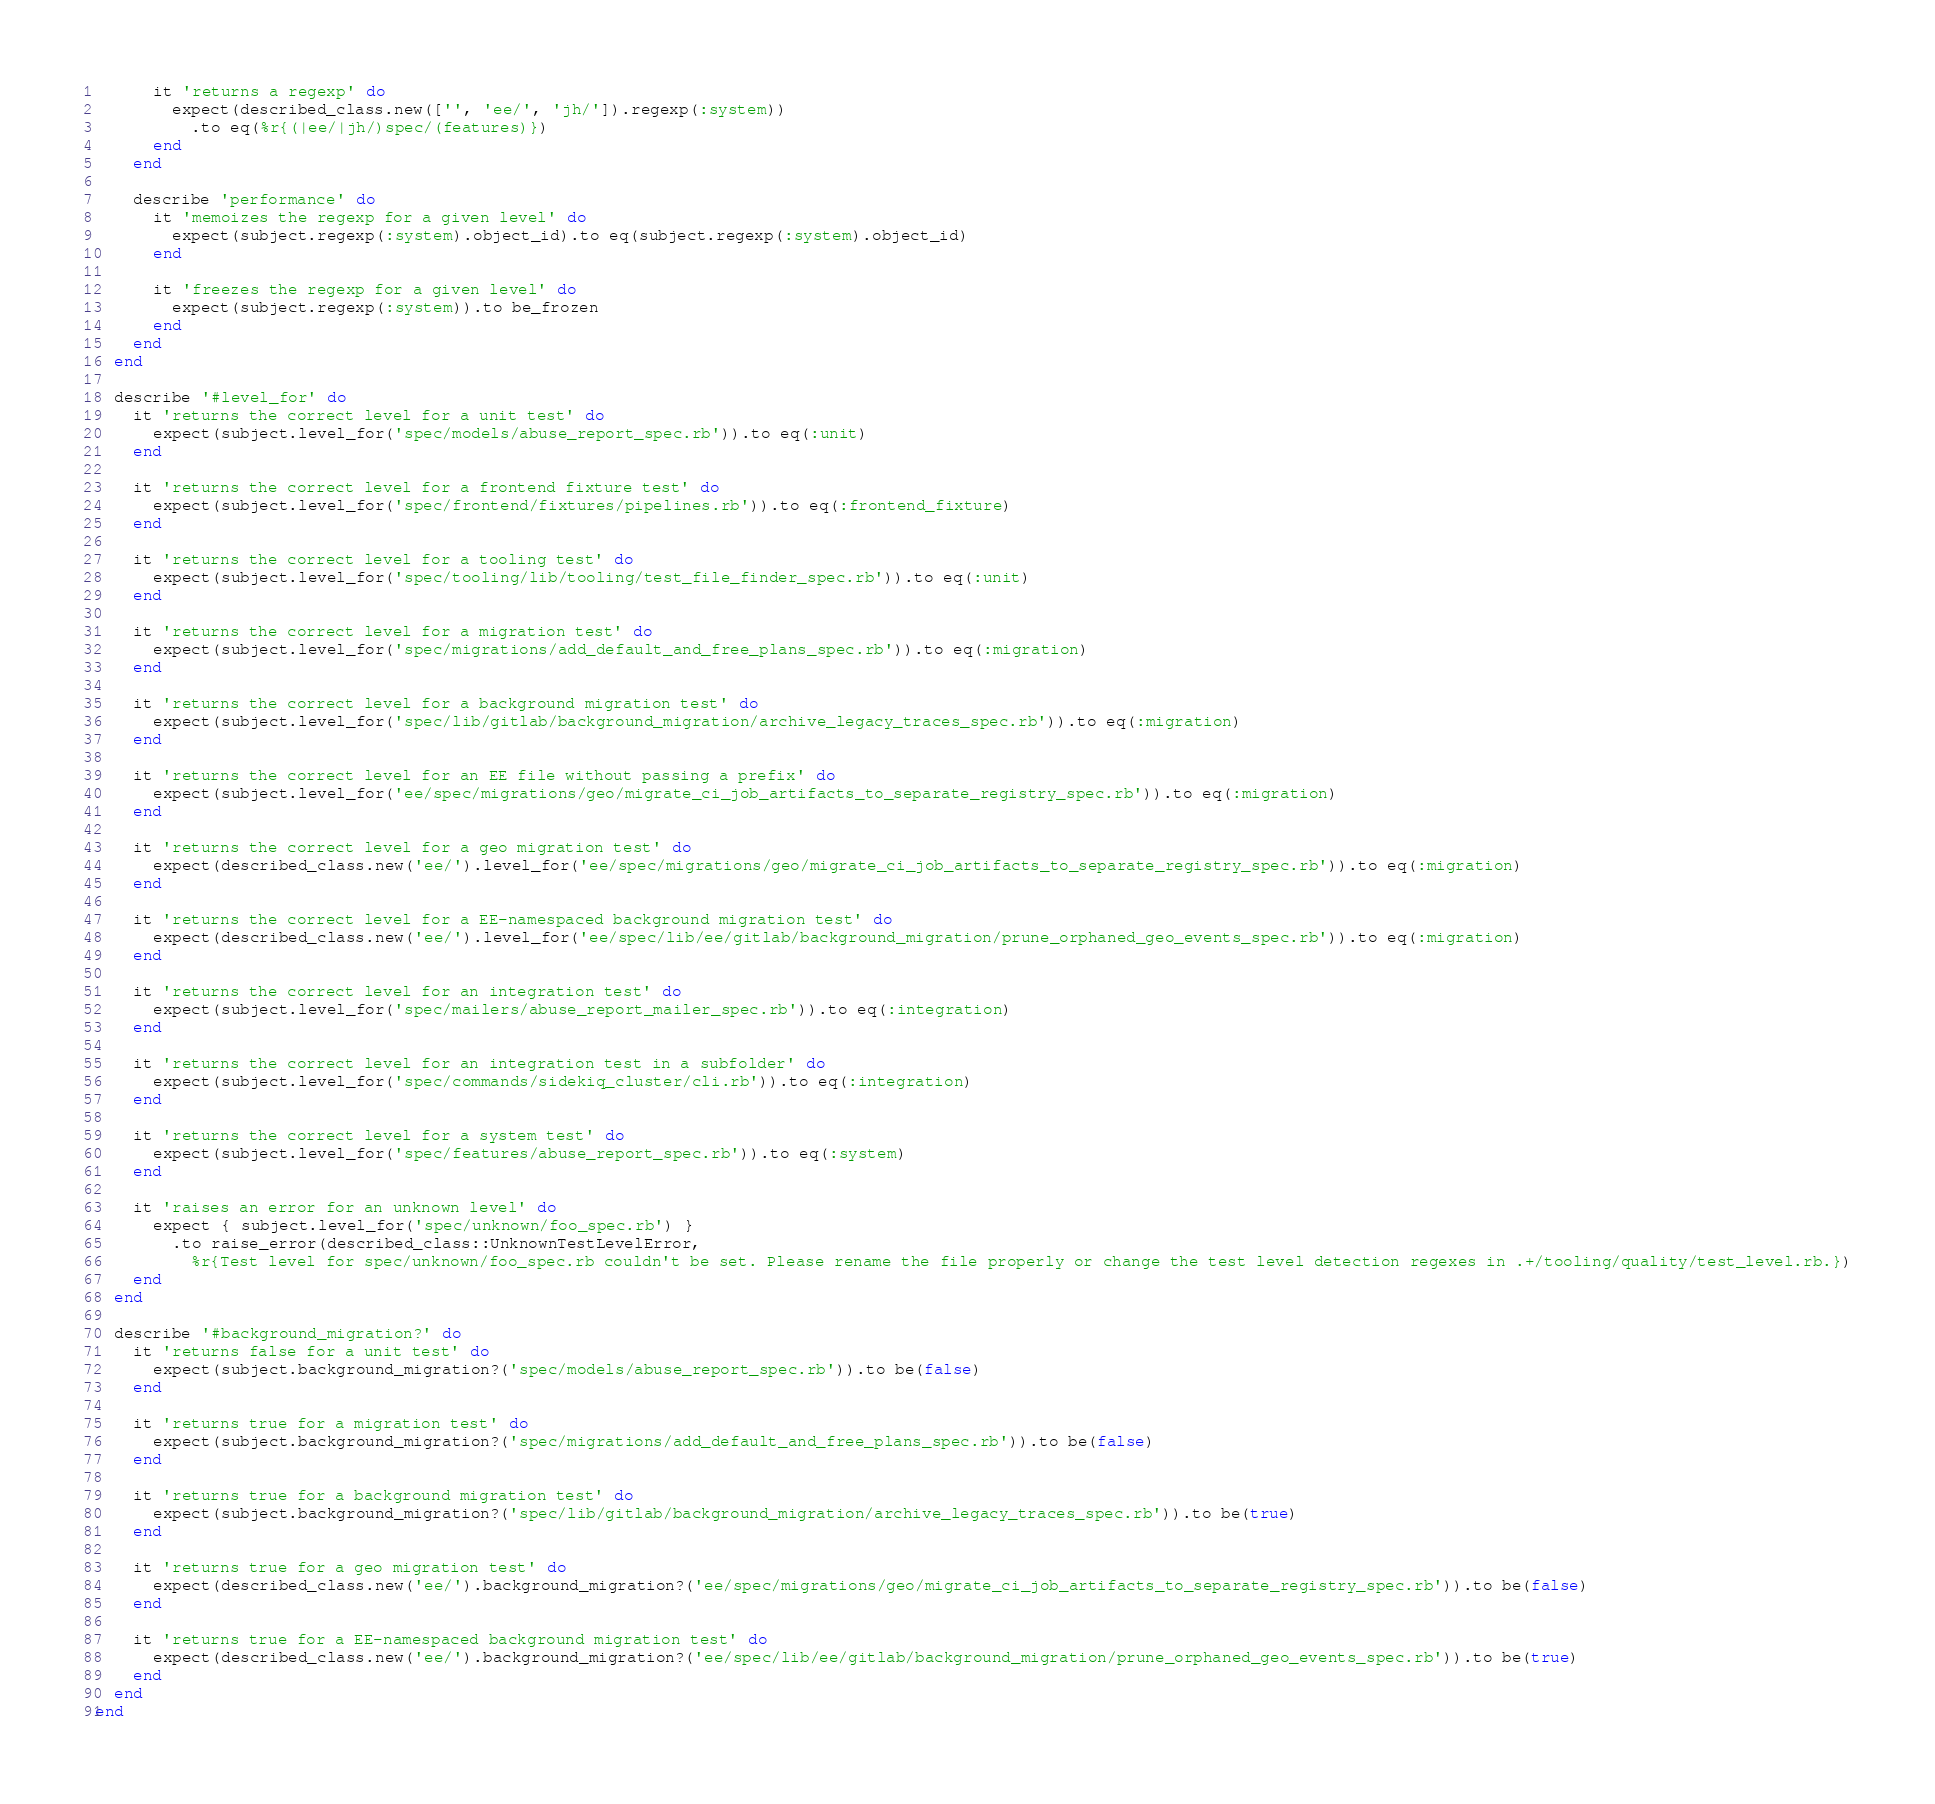Convert code to text. <code><loc_0><loc_0><loc_500><loc_500><_Ruby_>      it 'returns a regexp' do
        expect(described_class.new(['', 'ee/', 'jh/']).regexp(:system))
          .to eq(%r{(|ee/|jh/)spec/(features)})
      end
    end

    describe 'performance' do
      it 'memoizes the regexp for a given level' do
        expect(subject.regexp(:system).object_id).to eq(subject.regexp(:system).object_id)
      end

      it 'freezes the regexp for a given level' do
        expect(subject.regexp(:system)).to be_frozen
      end
    end
  end

  describe '#level_for' do
    it 'returns the correct level for a unit test' do
      expect(subject.level_for('spec/models/abuse_report_spec.rb')).to eq(:unit)
    end

    it 'returns the correct level for a frontend fixture test' do
      expect(subject.level_for('spec/frontend/fixtures/pipelines.rb')).to eq(:frontend_fixture)
    end

    it 'returns the correct level for a tooling test' do
      expect(subject.level_for('spec/tooling/lib/tooling/test_file_finder_spec.rb')).to eq(:unit)
    end

    it 'returns the correct level for a migration test' do
      expect(subject.level_for('spec/migrations/add_default_and_free_plans_spec.rb')).to eq(:migration)
    end

    it 'returns the correct level for a background migration test' do
      expect(subject.level_for('spec/lib/gitlab/background_migration/archive_legacy_traces_spec.rb')).to eq(:migration)
    end

    it 'returns the correct level for an EE file without passing a prefix' do
      expect(subject.level_for('ee/spec/migrations/geo/migrate_ci_job_artifacts_to_separate_registry_spec.rb')).to eq(:migration)
    end

    it 'returns the correct level for a geo migration test' do
      expect(described_class.new('ee/').level_for('ee/spec/migrations/geo/migrate_ci_job_artifacts_to_separate_registry_spec.rb')).to eq(:migration)
    end

    it 'returns the correct level for a EE-namespaced background migration test' do
      expect(described_class.new('ee/').level_for('ee/spec/lib/ee/gitlab/background_migration/prune_orphaned_geo_events_spec.rb')).to eq(:migration)
    end

    it 'returns the correct level for an integration test' do
      expect(subject.level_for('spec/mailers/abuse_report_mailer_spec.rb')).to eq(:integration)
    end

    it 'returns the correct level for an integration test in a subfolder' do
      expect(subject.level_for('spec/commands/sidekiq_cluster/cli.rb')).to eq(:integration)
    end

    it 'returns the correct level for a system test' do
      expect(subject.level_for('spec/features/abuse_report_spec.rb')).to eq(:system)
    end

    it 'raises an error for an unknown level' do
      expect { subject.level_for('spec/unknown/foo_spec.rb') }
        .to raise_error(described_class::UnknownTestLevelError,
          %r{Test level for spec/unknown/foo_spec.rb couldn't be set. Please rename the file properly or change the test level detection regexes in .+/tooling/quality/test_level.rb.})
    end
  end

  describe '#background_migration?' do
    it 'returns false for a unit test' do
      expect(subject.background_migration?('spec/models/abuse_report_spec.rb')).to be(false)
    end

    it 'returns true for a migration test' do
      expect(subject.background_migration?('spec/migrations/add_default_and_free_plans_spec.rb')).to be(false)
    end

    it 'returns true for a background migration test' do
      expect(subject.background_migration?('spec/lib/gitlab/background_migration/archive_legacy_traces_spec.rb')).to be(true)
    end

    it 'returns true for a geo migration test' do
      expect(described_class.new('ee/').background_migration?('ee/spec/migrations/geo/migrate_ci_job_artifacts_to_separate_registry_spec.rb')).to be(false)
    end

    it 'returns true for a EE-namespaced background migration test' do
      expect(described_class.new('ee/').background_migration?('ee/spec/lib/ee/gitlab/background_migration/prune_orphaned_geo_events_spec.rb')).to be(true)
    end
  end
end
</code> 